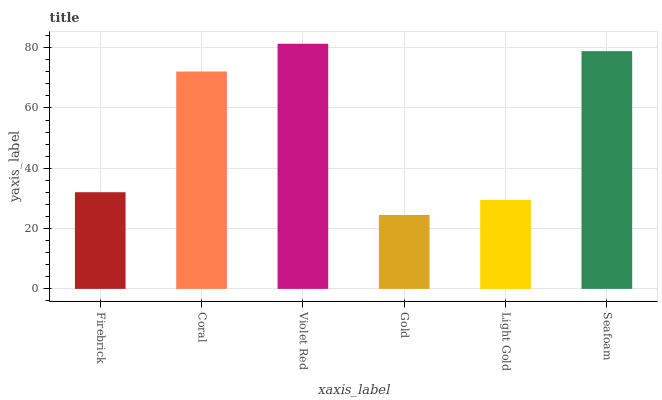Is Gold the minimum?
Answer yes or no. Yes. Is Violet Red the maximum?
Answer yes or no. Yes. Is Coral the minimum?
Answer yes or no. No. Is Coral the maximum?
Answer yes or no. No. Is Coral greater than Firebrick?
Answer yes or no. Yes. Is Firebrick less than Coral?
Answer yes or no. Yes. Is Firebrick greater than Coral?
Answer yes or no. No. Is Coral less than Firebrick?
Answer yes or no. No. Is Coral the high median?
Answer yes or no. Yes. Is Firebrick the low median?
Answer yes or no. Yes. Is Gold the high median?
Answer yes or no. No. Is Light Gold the low median?
Answer yes or no. No. 